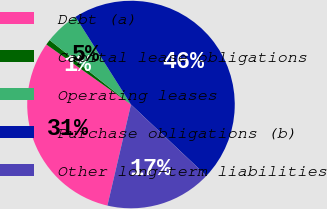Convert chart to OTSL. <chart><loc_0><loc_0><loc_500><loc_500><pie_chart><fcel>Debt (a)<fcel>Capital lease obligations<fcel>Operating leases<fcel>Purchase obligations (b)<fcel>Other long-term liabilities<nl><fcel>31.18%<fcel>0.84%<fcel>5.36%<fcel>46.03%<fcel>16.6%<nl></chart> 